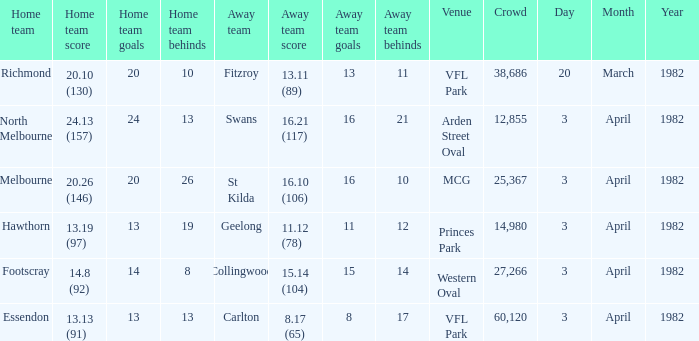Which team played as the home side when facing the away team of collingwood? Footscray. 